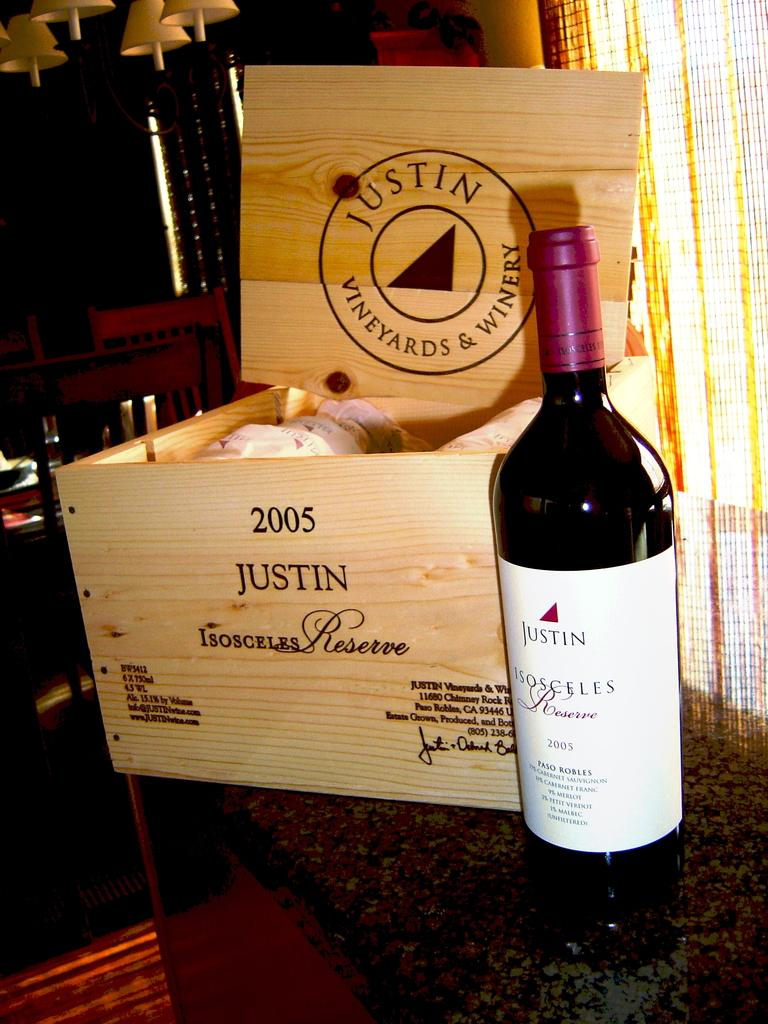<image>
Summarize the visual content of the image. A bottle of wine labeled "Justin" which was made in 2005 along with the box that the wine came with. 